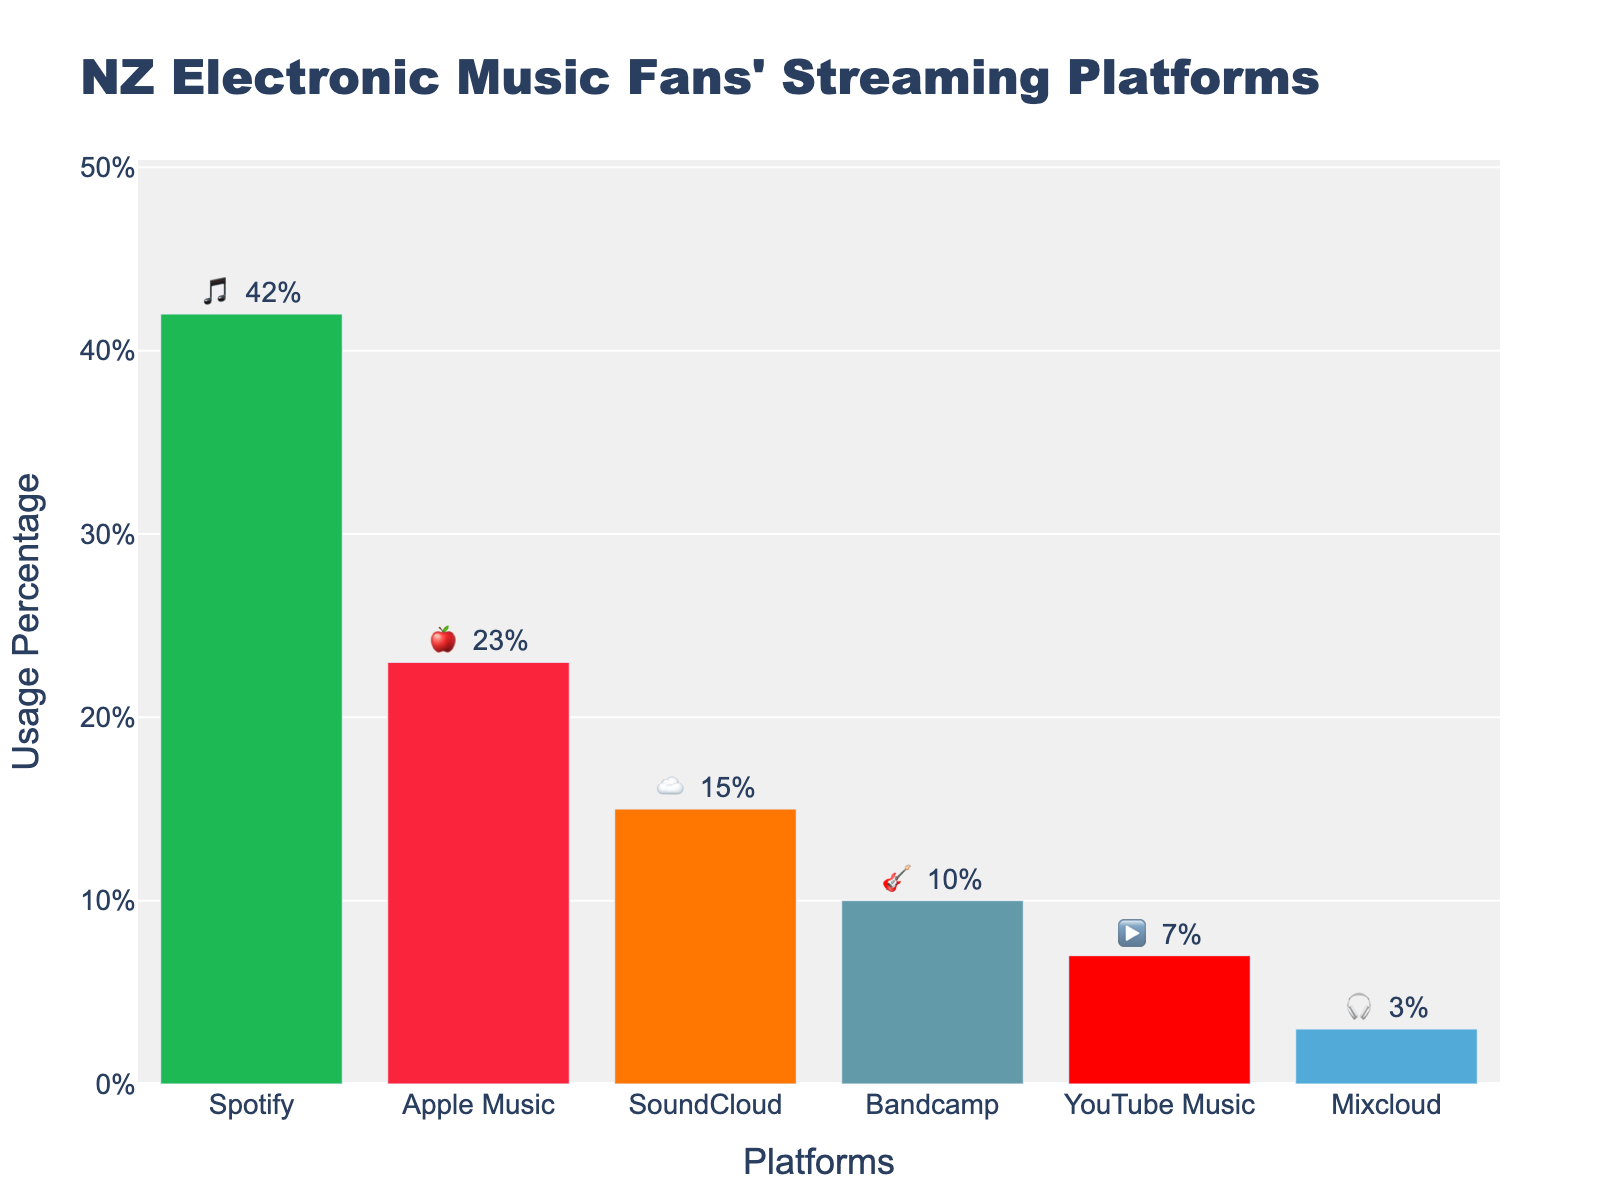*What is the title of the plot?* The plot's title can be found at the top of the figure. It reads, "NZ Electronic Music Fans' Streaming Platforms."
Answer: NZ Electronic Music Fans' Streaming Platforms *Which platform has the largest percentage of usage?* To determine the platform with the highest usage, compare the percentages of all platforms. Spotify has the highest percentage at 42%.
Answer: Spotify *What is the total percentage of usage for Apple Music and SoundCloud combined?* Add the percentages of Apple Music (23%) and SoundCloud (15%) together: 23% + 15% = 38%.
Answer: 38% *Is YouTube Music used more than Mixcloud?* Compare the percentage of YouTube Music (7%) with Mixcloud (3%). Since 7% is greater than 3%, YouTube Music is used more.
Answer: Yes *How much greater is Spotify's usage compared to Bandcamp?* Subtract Bandcamp's percentage (10%) from Spotify's percentage (42%): 42% - 10% = 32%.
Answer: 32% *What is the second most popular streaming platform among New Zealand electronic music fans?* The platform with the second-highest percentage is Apple Music at 23%, following Spotify.
Answer: Apple Music *Which streaming platform has the lowest percentage of usage?* The platform with the lowest percentage is Mixcloud with 3%.
Answer: Mixcloud *What is the average percentage of usage across all listed platforms?* Sum the percentages of all platforms (42 + 23 + 15 + 10 + 7 + 3 = 100) and divide by the number of platforms (6): 100 / 6 ≈ 16.67%.
Answer: 16.67% *What is the percentage difference between the most and the least used platforms?* Subtract Mixcloud's percentage (3%) from Spotify's percentage (42%): 42% - 3% = 39%.
Answer: 39% *Name two platforms whose combined usage is equal to YouTube Music and Bandcamp combined.* First, combine YouTube Music (7%) and Bandcamp (10%) for a total of 17%. Then look for two other platforms whose combined percentage equals 17%. SoundCloud (15%) and Mixcloud (3%) combined give 18%, while no direct pair sums to exactly 17%, so the closest is SoundCloud and Mixcloud.
Answer: SoundCloud and Mixcloud 